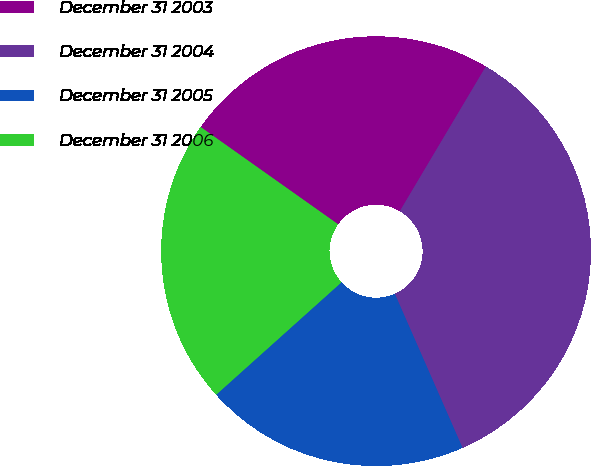<chart> <loc_0><loc_0><loc_500><loc_500><pie_chart><fcel>December 31 2003<fcel>December 31 2004<fcel>December 31 2005<fcel>December 31 2006<nl><fcel>23.73%<fcel>34.87%<fcel>19.95%<fcel>21.44%<nl></chart> 